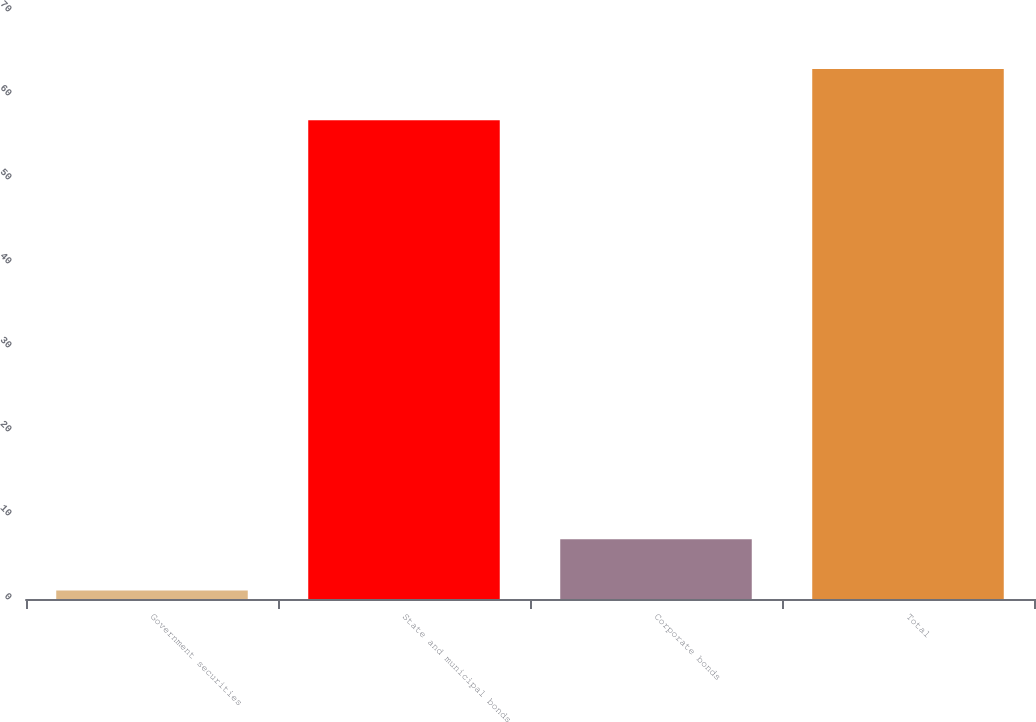Convert chart to OTSL. <chart><loc_0><loc_0><loc_500><loc_500><bar_chart><fcel>Government securities<fcel>State and municipal bonds<fcel>Corporate bonds<fcel>Total<nl><fcel>1<fcel>57<fcel>7.1<fcel>63.1<nl></chart> 